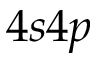<formula> <loc_0><loc_0><loc_500><loc_500>4 s 4 p</formula> 